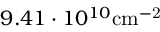Convert formula to latex. <formula><loc_0><loc_0><loc_500><loc_500>9 . 4 1 \cdot 1 0 ^ { 1 0 } { c m } ^ { - 2 }</formula> 